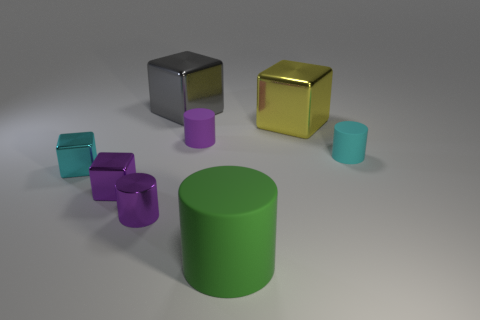Subtract all green balls. How many purple cylinders are left? 2 Subtract all rubber cylinders. How many cylinders are left? 1 Subtract all yellow cubes. How many cubes are left? 3 Subtract all red cylinders. Subtract all purple balls. How many cylinders are left? 4 Add 2 large gray metal things. How many objects exist? 10 Add 8 yellow cubes. How many yellow cubes exist? 9 Subtract 0 brown blocks. How many objects are left? 8 Subtract all small blue shiny cylinders. Subtract all small cyan cylinders. How many objects are left? 7 Add 8 gray metal objects. How many gray metal objects are left? 9 